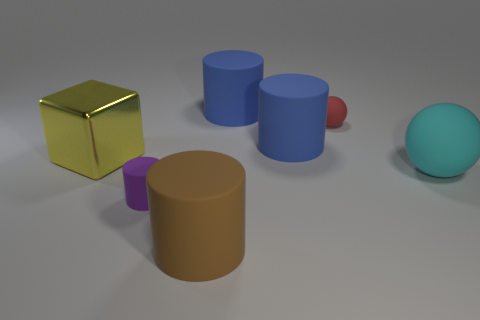Subtract all blue cylinders. How many were subtracted if there are1blue cylinders left? 1 Subtract all tiny purple rubber cylinders. How many cylinders are left? 3 Add 3 large cylinders. How many objects exist? 10 Subtract all yellow balls. How many blue cylinders are left? 2 Subtract all cylinders. How many objects are left? 3 Subtract 1 cylinders. How many cylinders are left? 3 Subtract all red balls. How many balls are left? 1 Add 4 matte things. How many matte things are left? 10 Add 7 yellow blocks. How many yellow blocks exist? 8 Subtract 0 green blocks. How many objects are left? 7 